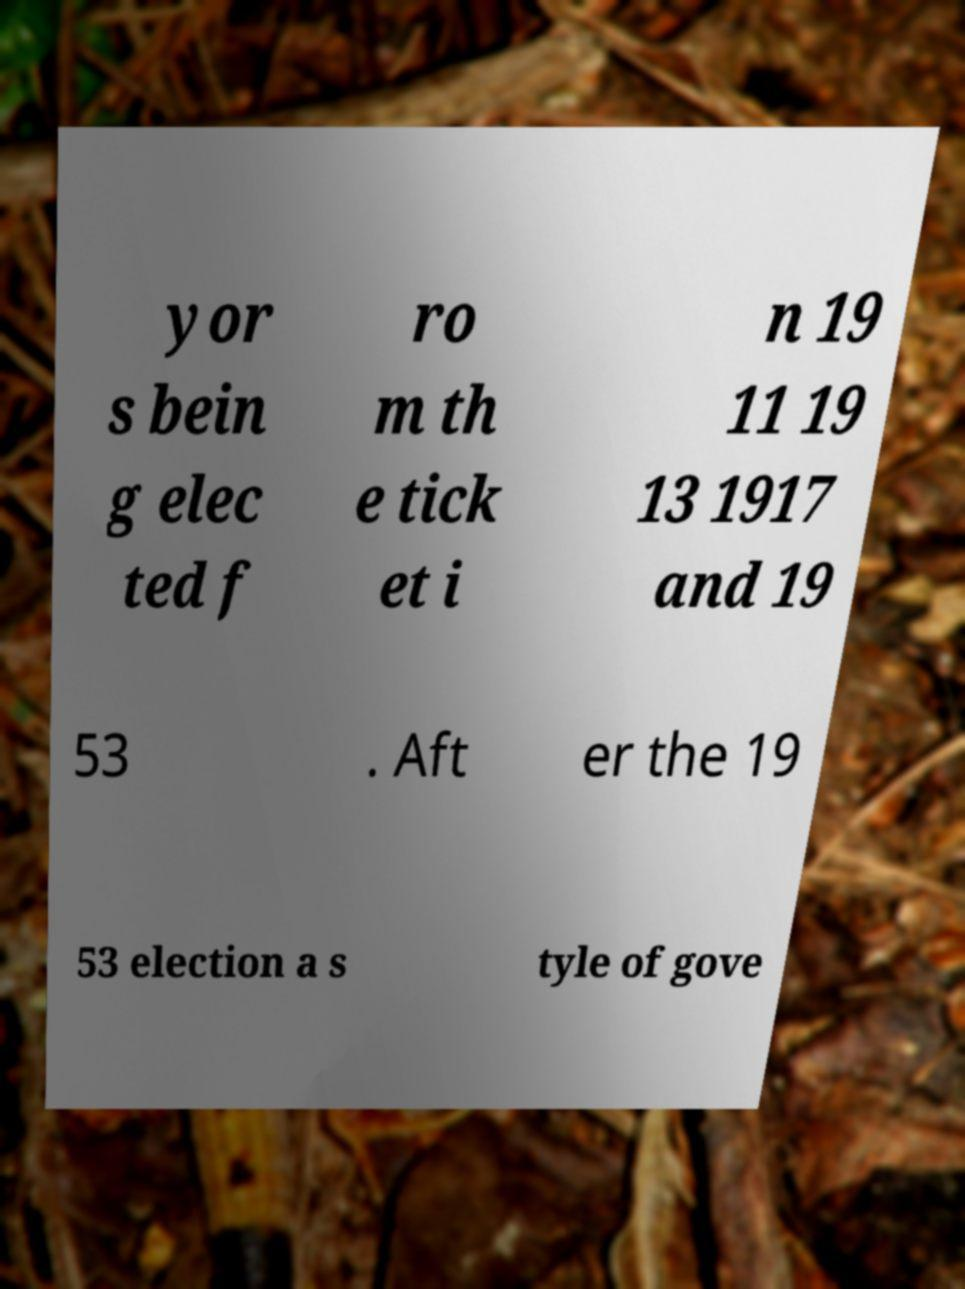Please identify and transcribe the text found in this image. yor s bein g elec ted f ro m th e tick et i n 19 11 19 13 1917 and 19 53 . Aft er the 19 53 election a s tyle of gove 